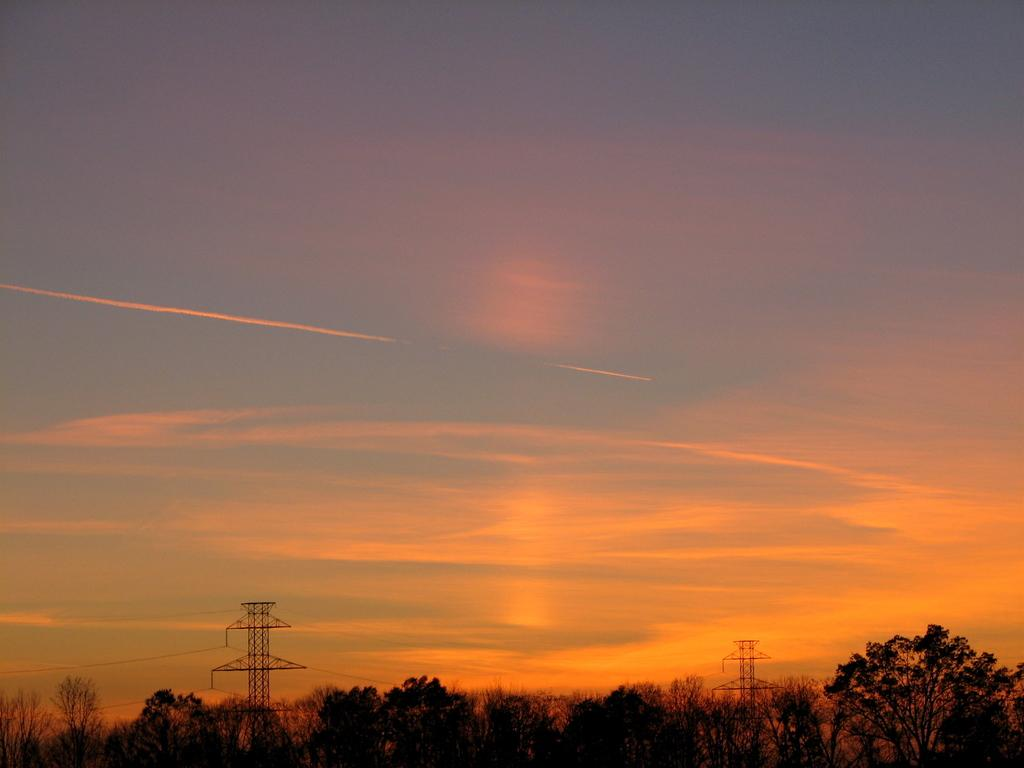What type of natural vegetation can be seen in the image? There are trees in the image. What man-made structures are present in the image? There are electric towers with cables in the image. What is visible at the top of the image? The sky is visible at the top of the image. What type of liquid is being produced by the trees in the image? There is no liquid being produced by the trees in the image; they are simply standing in the landscape. What part of the human body can be seen interacting with the electric towers in the image? There are no human body parts present in the image, including chins. 